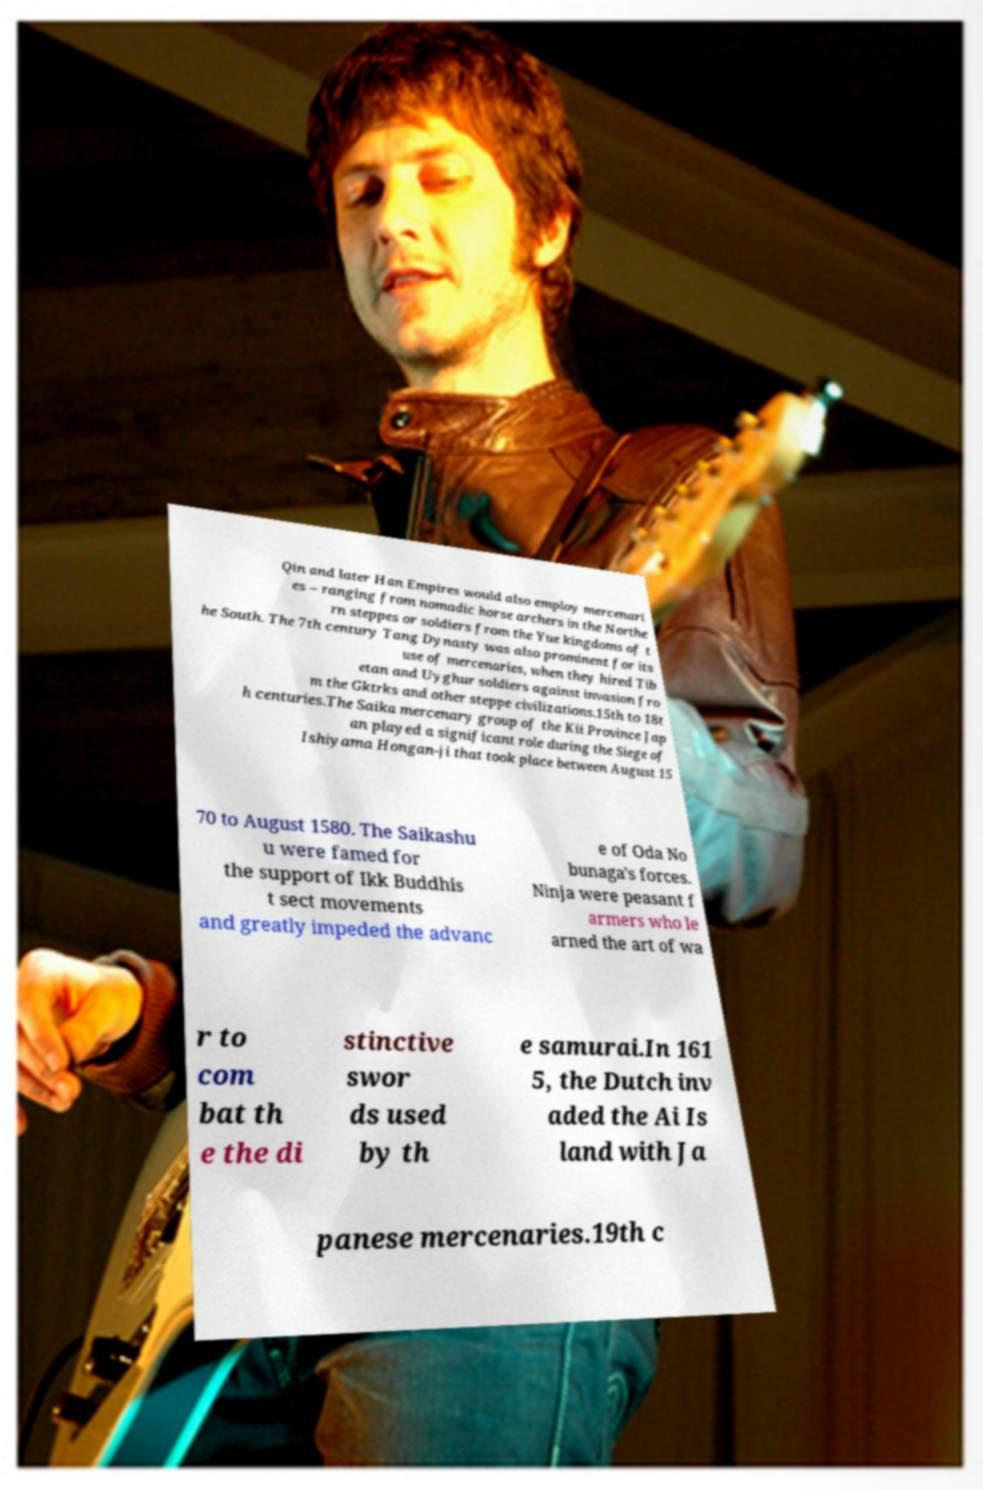Could you extract and type out the text from this image? Qin and later Han Empires would also employ mercenari es – ranging from nomadic horse archers in the Northe rn steppes or soldiers from the Yue kingdoms of t he South. The 7th century Tang Dynasty was also prominent for its use of mercenaries, when they hired Tib etan and Uyghur soldiers against invasion fro m the Gktrks and other steppe civilizations.15th to 18t h centuries.The Saika mercenary group of the Kii Province Jap an played a significant role during the Siege of Ishiyama Hongan-ji that took place between August 15 70 to August 1580. The Saikashu u were famed for the support of Ikk Buddhis t sect movements and greatly impeded the advanc e of Oda No bunaga's forces. Ninja were peasant f armers who le arned the art of wa r to com bat th e the di stinctive swor ds used by th e samurai.In 161 5, the Dutch inv aded the Ai Is land with Ja panese mercenaries.19th c 